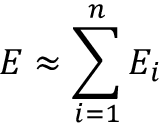Convert formula to latex. <formula><loc_0><loc_0><loc_500><loc_500>E \approx \sum _ { i = 1 } ^ { n } E _ { i }</formula> 